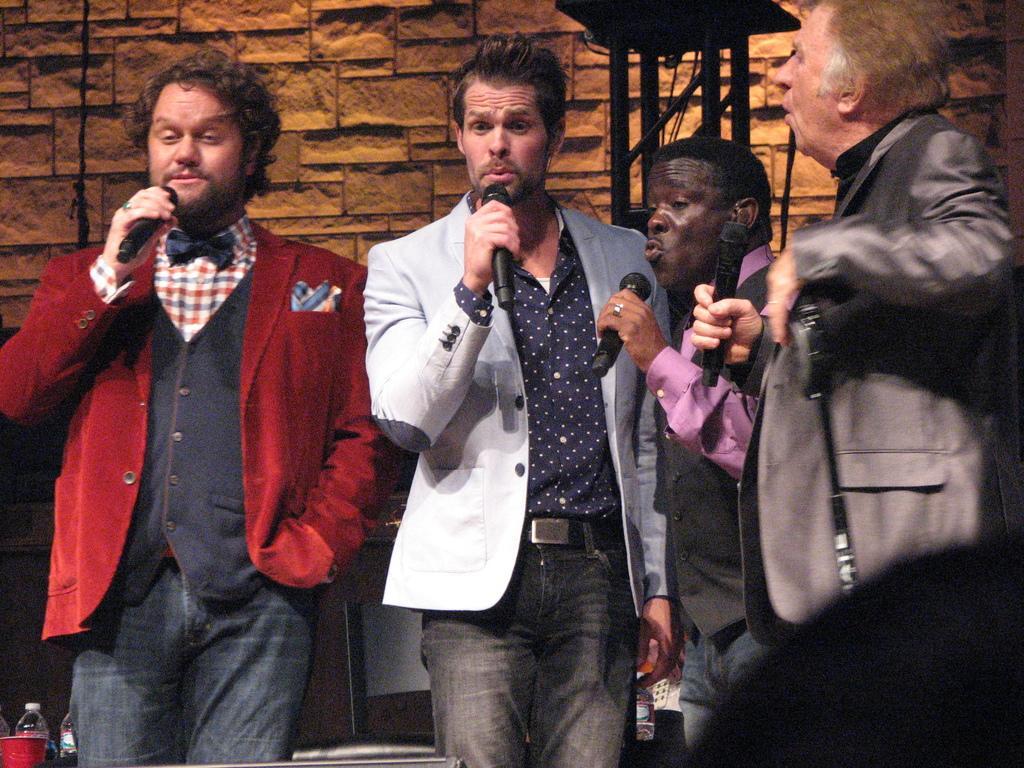In one or two sentences, can you explain what this image depicts? In the picture we can see four men are standing, holding the microphones and singing the song and behind them we can see the wall. 